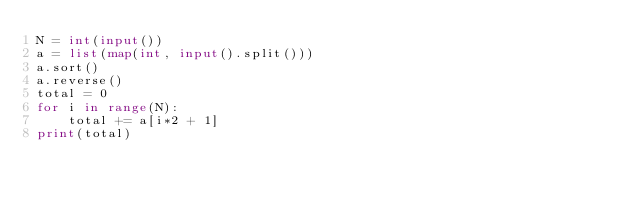<code> <loc_0><loc_0><loc_500><loc_500><_Python_>N = int(input())
a = list(map(int, input().split()))
a.sort()
a.reverse()
total = 0
for i in range(N):
    total += a[i*2 + 1]
print(total)
</code> 